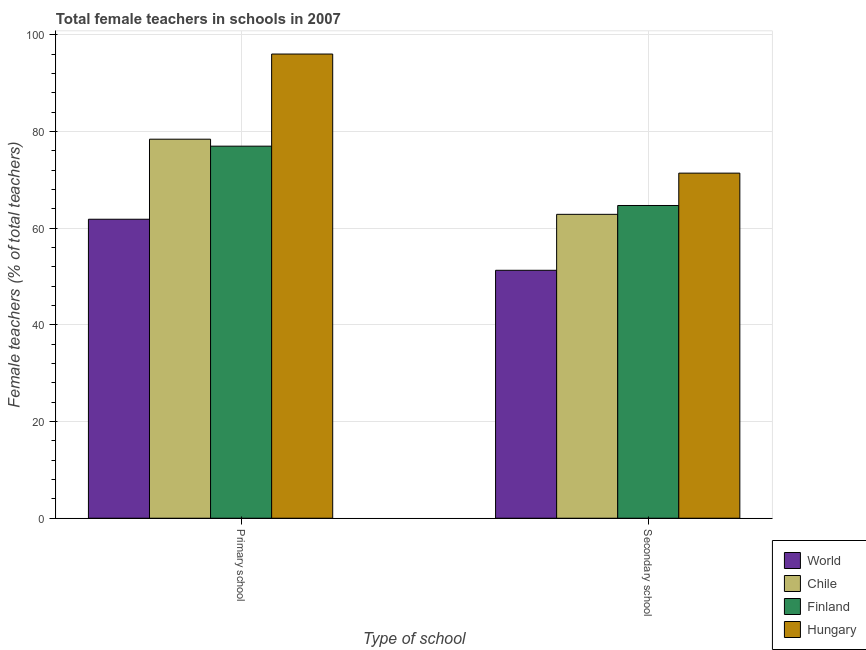Are the number of bars per tick equal to the number of legend labels?
Provide a succinct answer. Yes. Are the number of bars on each tick of the X-axis equal?
Keep it short and to the point. Yes. How many bars are there on the 2nd tick from the right?
Provide a short and direct response. 4. What is the label of the 1st group of bars from the left?
Make the answer very short. Primary school. What is the percentage of female teachers in primary schools in Chile?
Your answer should be very brief. 78.4. Across all countries, what is the maximum percentage of female teachers in secondary schools?
Ensure brevity in your answer.  71.38. Across all countries, what is the minimum percentage of female teachers in primary schools?
Give a very brief answer. 61.84. In which country was the percentage of female teachers in secondary schools maximum?
Ensure brevity in your answer.  Hungary. What is the total percentage of female teachers in secondary schools in the graph?
Provide a succinct answer. 250.21. What is the difference between the percentage of female teachers in primary schools in Chile and that in World?
Offer a very short reply. 16.55. What is the difference between the percentage of female teachers in secondary schools in Hungary and the percentage of female teachers in primary schools in World?
Ensure brevity in your answer.  9.54. What is the average percentage of female teachers in primary schools per country?
Offer a terse response. 78.3. What is the difference between the percentage of female teachers in secondary schools and percentage of female teachers in primary schools in Finland?
Provide a succinct answer. -12.27. What is the ratio of the percentage of female teachers in primary schools in Hungary to that in Finland?
Give a very brief answer. 1.25. Is the percentage of female teachers in primary schools in Hungary less than that in Chile?
Your response must be concise. No. What does the 2nd bar from the left in Primary school represents?
Provide a succinct answer. Chile. What does the 2nd bar from the right in Secondary school represents?
Your answer should be very brief. Finland. How many countries are there in the graph?
Your answer should be compact. 4. What is the difference between two consecutive major ticks on the Y-axis?
Make the answer very short. 20. Are the values on the major ticks of Y-axis written in scientific E-notation?
Provide a succinct answer. No. Does the graph contain any zero values?
Keep it short and to the point. No. Where does the legend appear in the graph?
Provide a short and direct response. Bottom right. What is the title of the graph?
Your response must be concise. Total female teachers in schools in 2007. Does "Kosovo" appear as one of the legend labels in the graph?
Your answer should be compact. No. What is the label or title of the X-axis?
Make the answer very short. Type of school. What is the label or title of the Y-axis?
Your answer should be compact. Female teachers (% of total teachers). What is the Female teachers (% of total teachers) of World in Primary school?
Keep it short and to the point. 61.84. What is the Female teachers (% of total teachers) in Chile in Primary school?
Your answer should be compact. 78.4. What is the Female teachers (% of total teachers) in Finland in Primary school?
Offer a very short reply. 76.96. What is the Female teachers (% of total teachers) in Hungary in Primary school?
Your response must be concise. 96.01. What is the Female teachers (% of total teachers) of World in Secondary school?
Your response must be concise. 51.28. What is the Female teachers (% of total teachers) in Chile in Secondary school?
Provide a succinct answer. 62.86. What is the Female teachers (% of total teachers) in Finland in Secondary school?
Give a very brief answer. 64.69. What is the Female teachers (% of total teachers) of Hungary in Secondary school?
Provide a short and direct response. 71.38. Across all Type of school, what is the maximum Female teachers (% of total teachers) of World?
Your answer should be very brief. 61.84. Across all Type of school, what is the maximum Female teachers (% of total teachers) in Chile?
Provide a short and direct response. 78.4. Across all Type of school, what is the maximum Female teachers (% of total teachers) of Finland?
Your answer should be very brief. 76.96. Across all Type of school, what is the maximum Female teachers (% of total teachers) in Hungary?
Make the answer very short. 96.01. Across all Type of school, what is the minimum Female teachers (% of total teachers) of World?
Your response must be concise. 51.28. Across all Type of school, what is the minimum Female teachers (% of total teachers) in Chile?
Provide a succinct answer. 62.86. Across all Type of school, what is the minimum Female teachers (% of total teachers) of Finland?
Your answer should be compact. 64.69. Across all Type of school, what is the minimum Female teachers (% of total teachers) of Hungary?
Offer a very short reply. 71.38. What is the total Female teachers (% of total teachers) of World in the graph?
Keep it short and to the point. 113.13. What is the total Female teachers (% of total teachers) of Chile in the graph?
Offer a very short reply. 141.25. What is the total Female teachers (% of total teachers) in Finland in the graph?
Provide a succinct answer. 141.64. What is the total Female teachers (% of total teachers) in Hungary in the graph?
Your answer should be very brief. 167.39. What is the difference between the Female teachers (% of total teachers) in World in Primary school and that in Secondary school?
Your answer should be compact. 10.56. What is the difference between the Female teachers (% of total teachers) in Chile in Primary school and that in Secondary school?
Your answer should be very brief. 15.54. What is the difference between the Female teachers (% of total teachers) in Finland in Primary school and that in Secondary school?
Make the answer very short. 12.27. What is the difference between the Female teachers (% of total teachers) in Hungary in Primary school and that in Secondary school?
Ensure brevity in your answer.  24.63. What is the difference between the Female teachers (% of total teachers) in World in Primary school and the Female teachers (% of total teachers) in Chile in Secondary school?
Your response must be concise. -1.01. What is the difference between the Female teachers (% of total teachers) of World in Primary school and the Female teachers (% of total teachers) of Finland in Secondary school?
Your answer should be compact. -2.84. What is the difference between the Female teachers (% of total teachers) of World in Primary school and the Female teachers (% of total teachers) of Hungary in Secondary school?
Your answer should be compact. -9.54. What is the difference between the Female teachers (% of total teachers) of Chile in Primary school and the Female teachers (% of total teachers) of Finland in Secondary school?
Make the answer very short. 13.71. What is the difference between the Female teachers (% of total teachers) in Chile in Primary school and the Female teachers (% of total teachers) in Hungary in Secondary school?
Your answer should be compact. 7.02. What is the difference between the Female teachers (% of total teachers) in Finland in Primary school and the Female teachers (% of total teachers) in Hungary in Secondary school?
Provide a short and direct response. 5.58. What is the average Female teachers (% of total teachers) of World per Type of school?
Ensure brevity in your answer.  56.56. What is the average Female teachers (% of total teachers) of Chile per Type of school?
Provide a short and direct response. 70.63. What is the average Female teachers (% of total teachers) in Finland per Type of school?
Your answer should be very brief. 70.82. What is the average Female teachers (% of total teachers) in Hungary per Type of school?
Your response must be concise. 83.7. What is the difference between the Female teachers (% of total teachers) of World and Female teachers (% of total teachers) of Chile in Primary school?
Provide a succinct answer. -16.55. What is the difference between the Female teachers (% of total teachers) in World and Female teachers (% of total teachers) in Finland in Primary school?
Provide a short and direct response. -15.11. What is the difference between the Female teachers (% of total teachers) in World and Female teachers (% of total teachers) in Hungary in Primary school?
Offer a very short reply. -34.17. What is the difference between the Female teachers (% of total teachers) of Chile and Female teachers (% of total teachers) of Finland in Primary school?
Give a very brief answer. 1.44. What is the difference between the Female teachers (% of total teachers) in Chile and Female teachers (% of total teachers) in Hungary in Primary school?
Give a very brief answer. -17.62. What is the difference between the Female teachers (% of total teachers) of Finland and Female teachers (% of total teachers) of Hungary in Primary school?
Keep it short and to the point. -19.06. What is the difference between the Female teachers (% of total teachers) in World and Female teachers (% of total teachers) in Chile in Secondary school?
Offer a very short reply. -11.57. What is the difference between the Female teachers (% of total teachers) in World and Female teachers (% of total teachers) in Finland in Secondary school?
Ensure brevity in your answer.  -13.4. What is the difference between the Female teachers (% of total teachers) of World and Female teachers (% of total teachers) of Hungary in Secondary school?
Your response must be concise. -20.09. What is the difference between the Female teachers (% of total teachers) of Chile and Female teachers (% of total teachers) of Finland in Secondary school?
Offer a very short reply. -1.83. What is the difference between the Female teachers (% of total teachers) in Chile and Female teachers (% of total teachers) in Hungary in Secondary school?
Your answer should be very brief. -8.52. What is the difference between the Female teachers (% of total teachers) of Finland and Female teachers (% of total teachers) of Hungary in Secondary school?
Offer a terse response. -6.69. What is the ratio of the Female teachers (% of total teachers) in World in Primary school to that in Secondary school?
Offer a very short reply. 1.21. What is the ratio of the Female teachers (% of total teachers) in Chile in Primary school to that in Secondary school?
Your response must be concise. 1.25. What is the ratio of the Female teachers (% of total teachers) of Finland in Primary school to that in Secondary school?
Offer a terse response. 1.19. What is the ratio of the Female teachers (% of total teachers) in Hungary in Primary school to that in Secondary school?
Your answer should be compact. 1.35. What is the difference between the highest and the second highest Female teachers (% of total teachers) in World?
Provide a succinct answer. 10.56. What is the difference between the highest and the second highest Female teachers (% of total teachers) of Chile?
Give a very brief answer. 15.54. What is the difference between the highest and the second highest Female teachers (% of total teachers) of Finland?
Your answer should be very brief. 12.27. What is the difference between the highest and the second highest Female teachers (% of total teachers) of Hungary?
Offer a very short reply. 24.63. What is the difference between the highest and the lowest Female teachers (% of total teachers) in World?
Your answer should be very brief. 10.56. What is the difference between the highest and the lowest Female teachers (% of total teachers) of Chile?
Provide a succinct answer. 15.54. What is the difference between the highest and the lowest Female teachers (% of total teachers) in Finland?
Make the answer very short. 12.27. What is the difference between the highest and the lowest Female teachers (% of total teachers) in Hungary?
Keep it short and to the point. 24.63. 